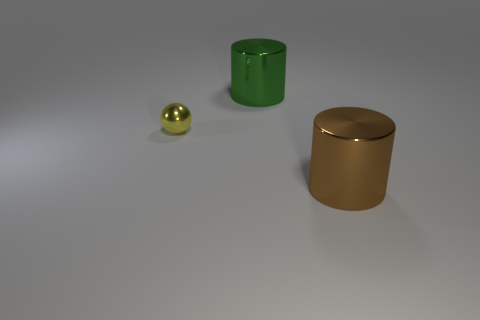How many other things are there of the same size as the yellow object?
Your answer should be very brief. 0. What is the shape of the big thing that is to the right of the big cylinder that is on the left side of the big brown thing?
Provide a short and direct response. Cylinder. There is a large metal cylinder that is behind the big brown shiny cylinder; does it have the same color as the big cylinder in front of the big green object?
Keep it short and to the point. No. Is there anything else that is the same color as the small sphere?
Provide a short and direct response. No. The shiny ball is what color?
Your answer should be compact. Yellow. Are any yellow cubes visible?
Provide a succinct answer. No. There is a big green thing; are there any big green shiny objects behind it?
Offer a terse response. No. There is another object that is the same shape as the brown object; what is it made of?
Provide a succinct answer. Metal. Is there anything else that has the same material as the large brown cylinder?
Ensure brevity in your answer.  Yes. How many other objects are there of the same shape as the yellow object?
Your answer should be compact. 0. 